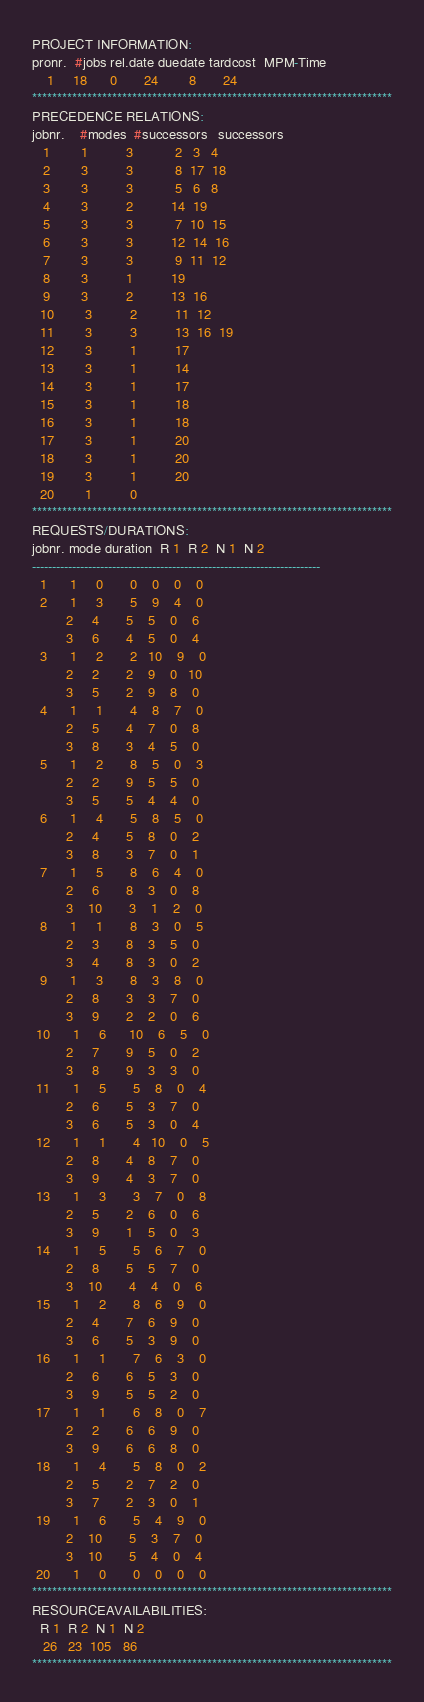Convert code to text. <code><loc_0><loc_0><loc_500><loc_500><_ObjectiveC_>PROJECT INFORMATION:
pronr.  #jobs rel.date duedate tardcost  MPM-Time
    1     18      0       24        8       24
************************************************************************
PRECEDENCE RELATIONS:
jobnr.    #modes  #successors   successors
   1        1          3           2   3   4
   2        3          3           8  17  18
   3        3          3           5   6   8
   4        3          2          14  19
   5        3          3           7  10  15
   6        3          3          12  14  16
   7        3          3           9  11  12
   8        3          1          19
   9        3          2          13  16
  10        3          2          11  12
  11        3          3          13  16  19
  12        3          1          17
  13        3          1          14
  14        3          1          17
  15        3          1          18
  16        3          1          18
  17        3          1          20
  18        3          1          20
  19        3          1          20
  20        1          0        
************************************************************************
REQUESTS/DURATIONS:
jobnr. mode duration  R 1  R 2  N 1  N 2
------------------------------------------------------------------------
  1      1     0       0    0    0    0
  2      1     3       5    9    4    0
         2     4       5    5    0    6
         3     6       4    5    0    4
  3      1     2       2   10    9    0
         2     2       2    9    0   10
         3     5       2    9    8    0
  4      1     1       4    8    7    0
         2     5       4    7    0    8
         3     8       3    4    5    0
  5      1     2       8    5    0    3
         2     2       9    5    5    0
         3     5       5    4    4    0
  6      1     4       5    8    5    0
         2     4       5    8    0    2
         3     8       3    7    0    1
  7      1     5       8    6    4    0
         2     6       8    3    0    8
         3    10       3    1    2    0
  8      1     1       8    3    0    5
         2     3       8    3    5    0
         3     4       8    3    0    2
  9      1     3       8    3    8    0
         2     8       3    3    7    0
         3     9       2    2    0    6
 10      1     6      10    6    5    0
         2     7       9    5    0    2
         3     8       9    3    3    0
 11      1     5       5    8    0    4
         2     6       5    3    7    0
         3     6       5    3    0    4
 12      1     1       4   10    0    5
         2     8       4    8    7    0
         3     9       4    3    7    0
 13      1     3       3    7    0    8
         2     5       2    6    0    6
         3     9       1    5    0    3
 14      1     5       5    6    7    0
         2     8       5    5    7    0
         3    10       4    4    0    6
 15      1     2       8    6    9    0
         2     4       7    6    9    0
         3     6       5    3    9    0
 16      1     1       7    6    3    0
         2     6       6    5    3    0
         3     9       5    5    2    0
 17      1     1       6    8    0    7
         2     2       6    6    9    0
         3     9       6    6    8    0
 18      1     4       5    8    0    2
         2     5       2    7    2    0
         3     7       2    3    0    1
 19      1     6       5    4    9    0
         2    10       5    3    7    0
         3    10       5    4    0    4
 20      1     0       0    0    0    0
************************************************************************
RESOURCEAVAILABILITIES:
  R 1  R 2  N 1  N 2
   26   23  105   86
************************************************************************
</code> 